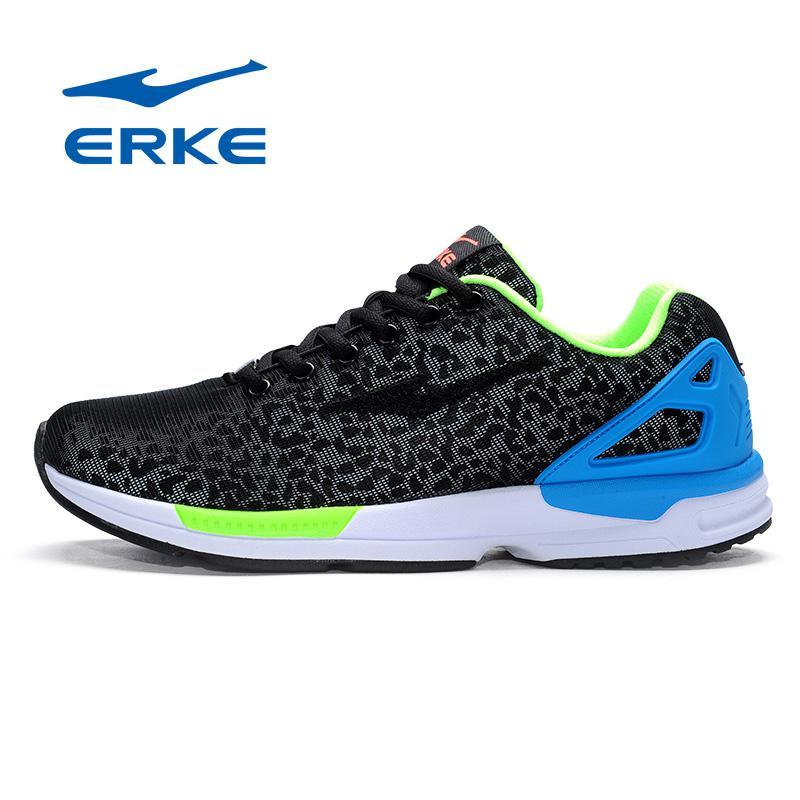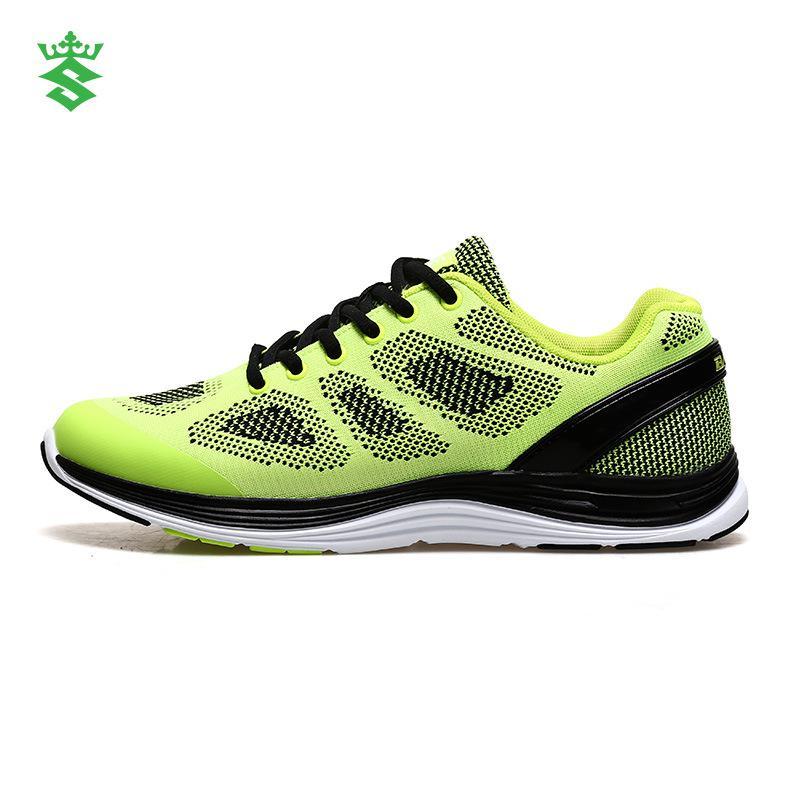The first image is the image on the left, the second image is the image on the right. Evaluate the accuracy of this statement regarding the images: "All shoes are laced with black shoestrings.". Is it true? Answer yes or no. Yes. The first image is the image on the left, the second image is the image on the right. For the images shown, is this caption "One shoe has a blue heel." true? Answer yes or no. Yes. 